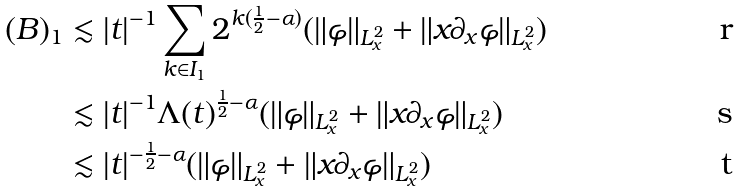<formula> <loc_0><loc_0><loc_500><loc_500>( B ) _ { 1 } & \lesssim | t | ^ { - 1 } \sum _ { k \in I _ { 1 } } 2 ^ { k ( \frac { 1 } { 2 } - \alpha ) } ( \| \varphi \| _ { L _ { x } ^ { 2 } } + \| x \partial _ { x } \varphi \| _ { L _ { x } ^ { 2 } } ) \\ & \lesssim | t | ^ { - 1 } \Lambda ( t ) ^ { \frac { 1 } { 2 } - \alpha } ( \| \varphi \| _ { L _ { x } ^ { 2 } } + \| x \partial _ { x } \varphi \| _ { L _ { x } ^ { 2 } } ) \\ & \lesssim | t | ^ { - \frac { 1 } { 2 } - \alpha } ( \| \varphi \| _ { L _ { x } ^ { 2 } } + \| x \partial _ { x } \varphi \| _ { L _ { x } ^ { 2 } } )</formula> 